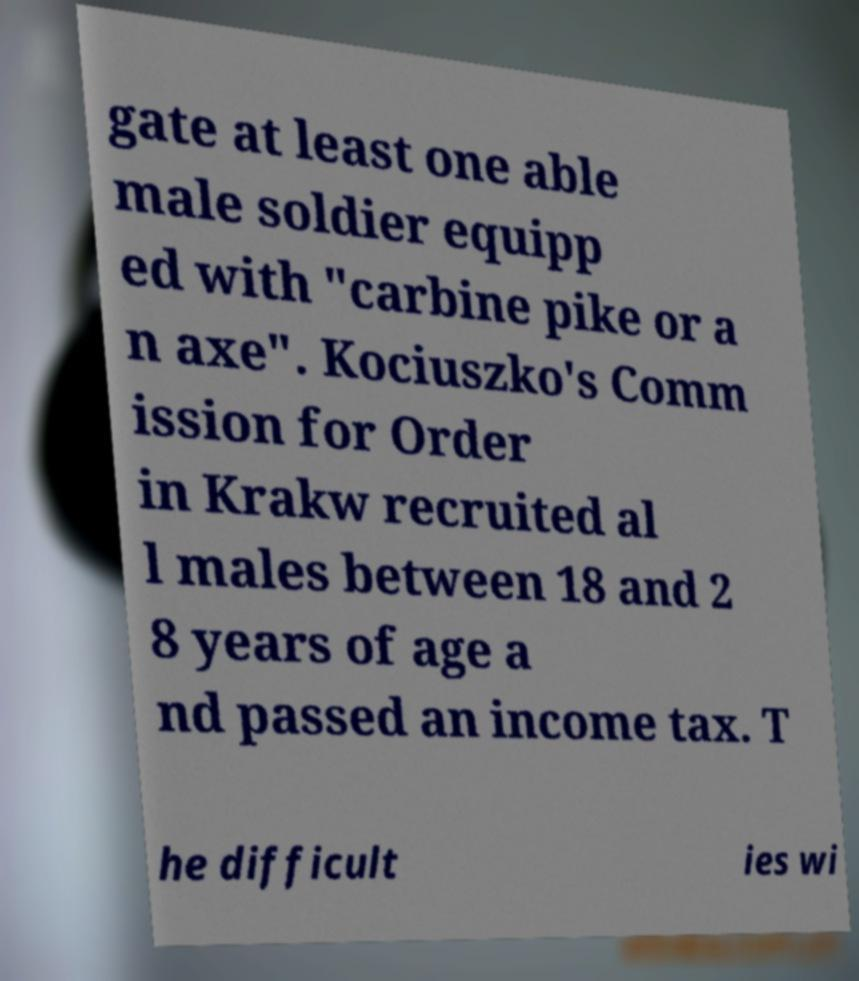Could you assist in decoding the text presented in this image and type it out clearly? gate at least one able male soldier equipp ed with "carbine pike or a n axe". Kociuszko's Comm ission for Order in Krakw recruited al l males between 18 and 2 8 years of age a nd passed an income tax. T he difficult ies wi 